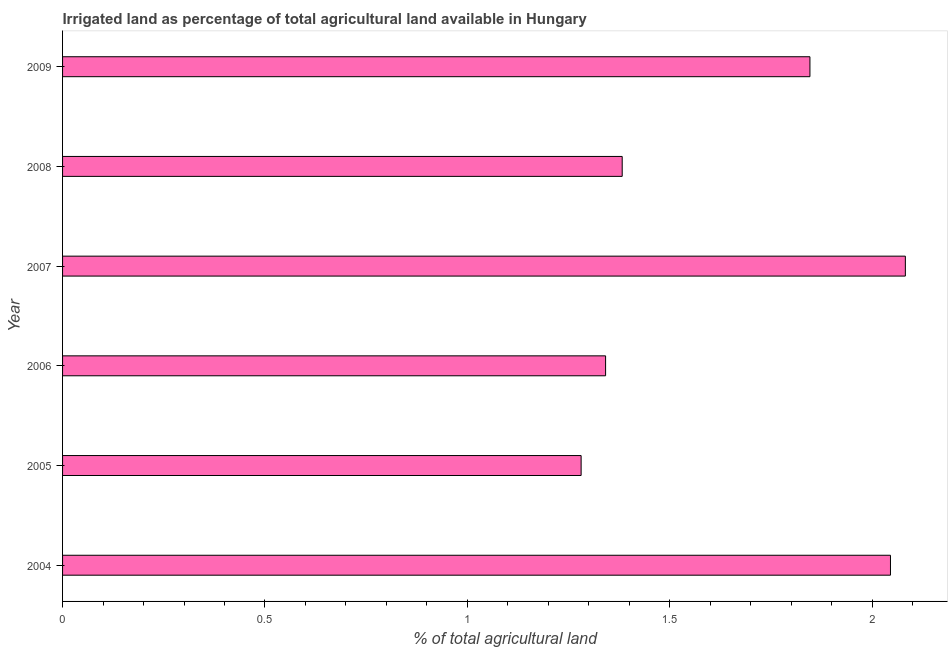What is the title of the graph?
Provide a succinct answer. Irrigated land as percentage of total agricultural land available in Hungary. What is the label or title of the X-axis?
Your answer should be very brief. % of total agricultural land. What is the percentage of agricultural irrigated land in 2008?
Your answer should be compact. 1.38. Across all years, what is the maximum percentage of agricultural irrigated land?
Offer a terse response. 2.08. Across all years, what is the minimum percentage of agricultural irrigated land?
Your answer should be very brief. 1.28. What is the sum of the percentage of agricultural irrigated land?
Your answer should be very brief. 9.98. What is the difference between the percentage of agricultural irrigated land in 2004 and 2009?
Your response must be concise. 0.2. What is the average percentage of agricultural irrigated land per year?
Keep it short and to the point. 1.66. What is the median percentage of agricultural irrigated land?
Offer a terse response. 1.61. In how many years, is the percentage of agricultural irrigated land greater than 1.4 %?
Provide a short and direct response. 3. What is the ratio of the percentage of agricultural irrigated land in 2005 to that in 2006?
Provide a short and direct response. 0.95. Is the percentage of agricultural irrigated land in 2005 less than that in 2008?
Provide a succinct answer. Yes. Is the difference between the percentage of agricultural irrigated land in 2004 and 2007 greater than the difference between any two years?
Keep it short and to the point. No. What is the difference between the highest and the second highest percentage of agricultural irrigated land?
Your response must be concise. 0.04. Is the sum of the percentage of agricultural irrigated land in 2007 and 2008 greater than the maximum percentage of agricultural irrigated land across all years?
Offer a very short reply. Yes. What is the difference between the highest and the lowest percentage of agricultural irrigated land?
Keep it short and to the point. 0.8. How many bars are there?
Provide a succinct answer. 6. How many years are there in the graph?
Your response must be concise. 6. What is the difference between two consecutive major ticks on the X-axis?
Make the answer very short. 0.5. Are the values on the major ticks of X-axis written in scientific E-notation?
Your response must be concise. No. What is the % of total agricultural land in 2004?
Provide a succinct answer. 2.05. What is the % of total agricultural land of 2005?
Your answer should be very brief. 1.28. What is the % of total agricultural land of 2006?
Provide a succinct answer. 1.34. What is the % of total agricultural land of 2007?
Your answer should be very brief. 2.08. What is the % of total agricultural land of 2008?
Provide a succinct answer. 1.38. What is the % of total agricultural land of 2009?
Ensure brevity in your answer.  1.85. What is the difference between the % of total agricultural land in 2004 and 2005?
Make the answer very short. 0.76. What is the difference between the % of total agricultural land in 2004 and 2006?
Your answer should be very brief. 0.7. What is the difference between the % of total agricultural land in 2004 and 2007?
Offer a very short reply. -0.04. What is the difference between the % of total agricultural land in 2004 and 2008?
Keep it short and to the point. 0.66. What is the difference between the % of total agricultural land in 2004 and 2009?
Provide a short and direct response. 0.2. What is the difference between the % of total agricultural land in 2005 and 2006?
Give a very brief answer. -0.06. What is the difference between the % of total agricultural land in 2005 and 2007?
Offer a very short reply. -0.8. What is the difference between the % of total agricultural land in 2005 and 2008?
Keep it short and to the point. -0.1. What is the difference between the % of total agricultural land in 2005 and 2009?
Your answer should be compact. -0.57. What is the difference between the % of total agricultural land in 2006 and 2007?
Your answer should be compact. -0.74. What is the difference between the % of total agricultural land in 2006 and 2008?
Make the answer very short. -0.04. What is the difference between the % of total agricultural land in 2006 and 2009?
Keep it short and to the point. -0.5. What is the difference between the % of total agricultural land in 2007 and 2008?
Provide a short and direct response. 0.7. What is the difference between the % of total agricultural land in 2007 and 2009?
Offer a terse response. 0.24. What is the difference between the % of total agricultural land in 2008 and 2009?
Your answer should be compact. -0.46. What is the ratio of the % of total agricultural land in 2004 to that in 2005?
Your answer should be compact. 1.6. What is the ratio of the % of total agricultural land in 2004 to that in 2006?
Keep it short and to the point. 1.52. What is the ratio of the % of total agricultural land in 2004 to that in 2007?
Keep it short and to the point. 0.98. What is the ratio of the % of total agricultural land in 2004 to that in 2008?
Offer a terse response. 1.48. What is the ratio of the % of total agricultural land in 2004 to that in 2009?
Your answer should be very brief. 1.11. What is the ratio of the % of total agricultural land in 2005 to that in 2006?
Give a very brief answer. 0.95. What is the ratio of the % of total agricultural land in 2005 to that in 2007?
Your answer should be compact. 0.61. What is the ratio of the % of total agricultural land in 2005 to that in 2008?
Your response must be concise. 0.93. What is the ratio of the % of total agricultural land in 2005 to that in 2009?
Your answer should be compact. 0.69. What is the ratio of the % of total agricultural land in 2006 to that in 2007?
Offer a very short reply. 0.64. What is the ratio of the % of total agricultural land in 2006 to that in 2008?
Ensure brevity in your answer.  0.97. What is the ratio of the % of total agricultural land in 2006 to that in 2009?
Offer a terse response. 0.73. What is the ratio of the % of total agricultural land in 2007 to that in 2008?
Your response must be concise. 1.51. What is the ratio of the % of total agricultural land in 2007 to that in 2009?
Keep it short and to the point. 1.13. What is the ratio of the % of total agricultural land in 2008 to that in 2009?
Keep it short and to the point. 0.75. 